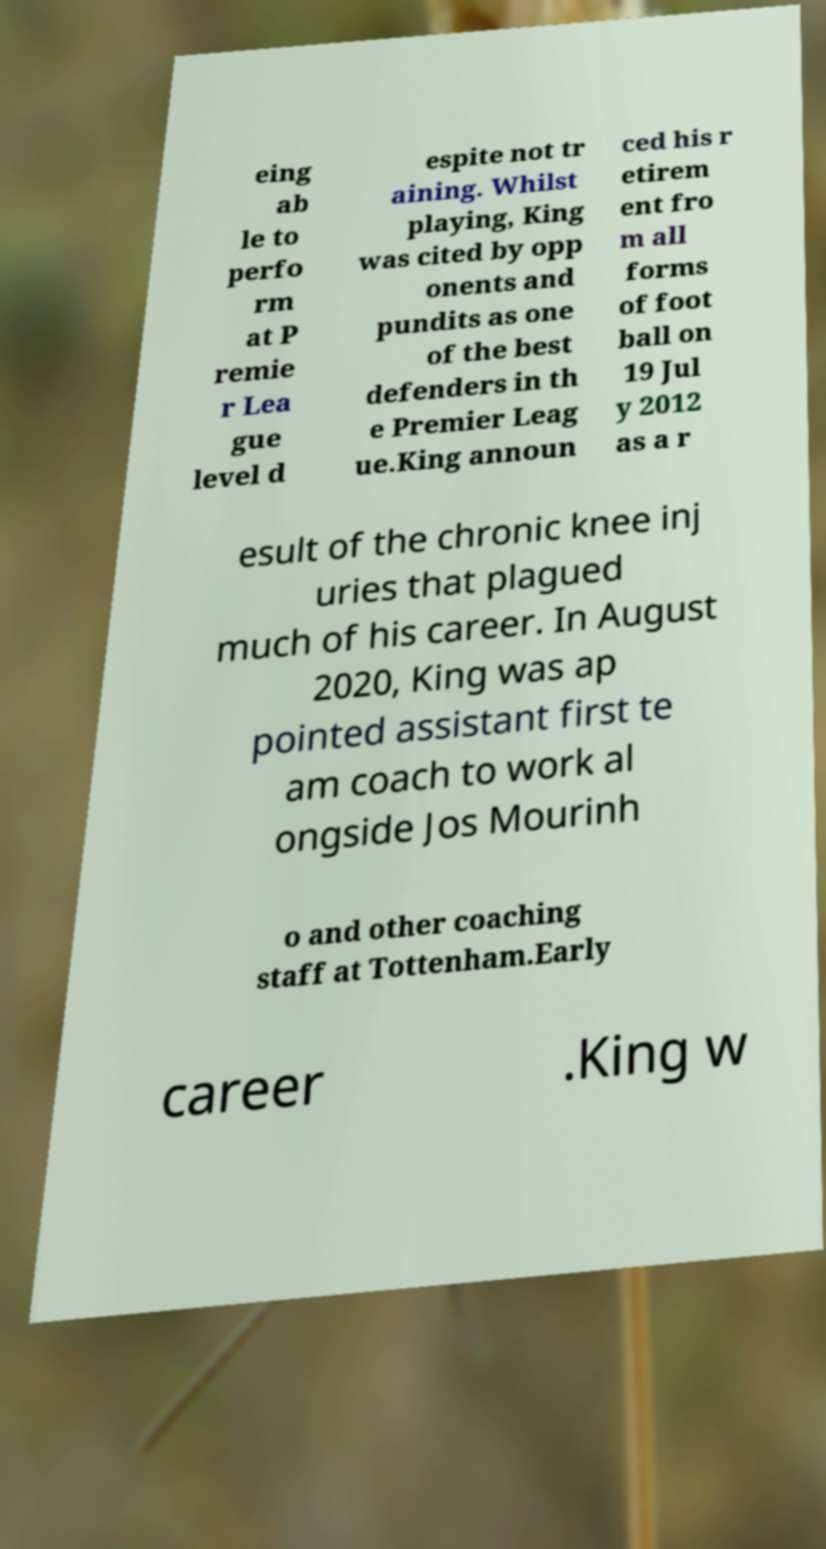Please identify and transcribe the text found in this image. eing ab le to perfo rm at P remie r Lea gue level d espite not tr aining. Whilst playing, King was cited by opp onents and pundits as one of the best defenders in th e Premier Leag ue.King announ ced his r etirem ent fro m all forms of foot ball on 19 Jul y 2012 as a r esult of the chronic knee inj uries that plagued much of his career. In August 2020, King was ap pointed assistant first te am coach to work al ongside Jos Mourinh o and other coaching staff at Tottenham.Early career .King w 